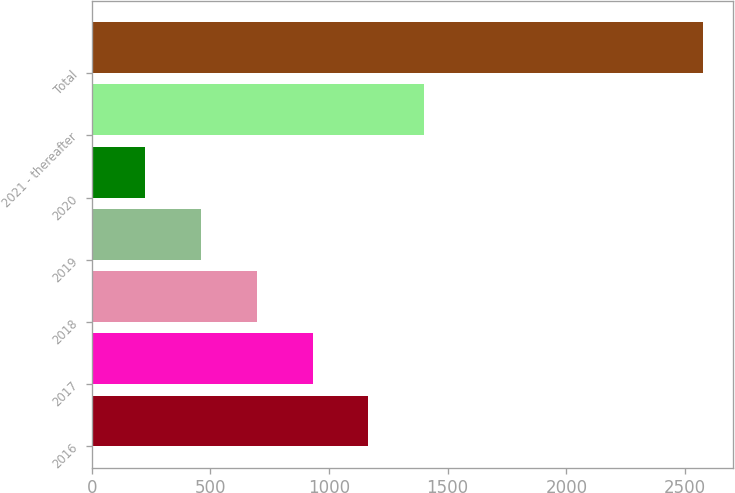<chart> <loc_0><loc_0><loc_500><loc_500><bar_chart><fcel>2016<fcel>2017<fcel>2018<fcel>2019<fcel>2020<fcel>2021 - thereafter<fcel>Total<nl><fcel>1165.6<fcel>930.7<fcel>695.8<fcel>460.9<fcel>226<fcel>1400.5<fcel>2575<nl></chart> 